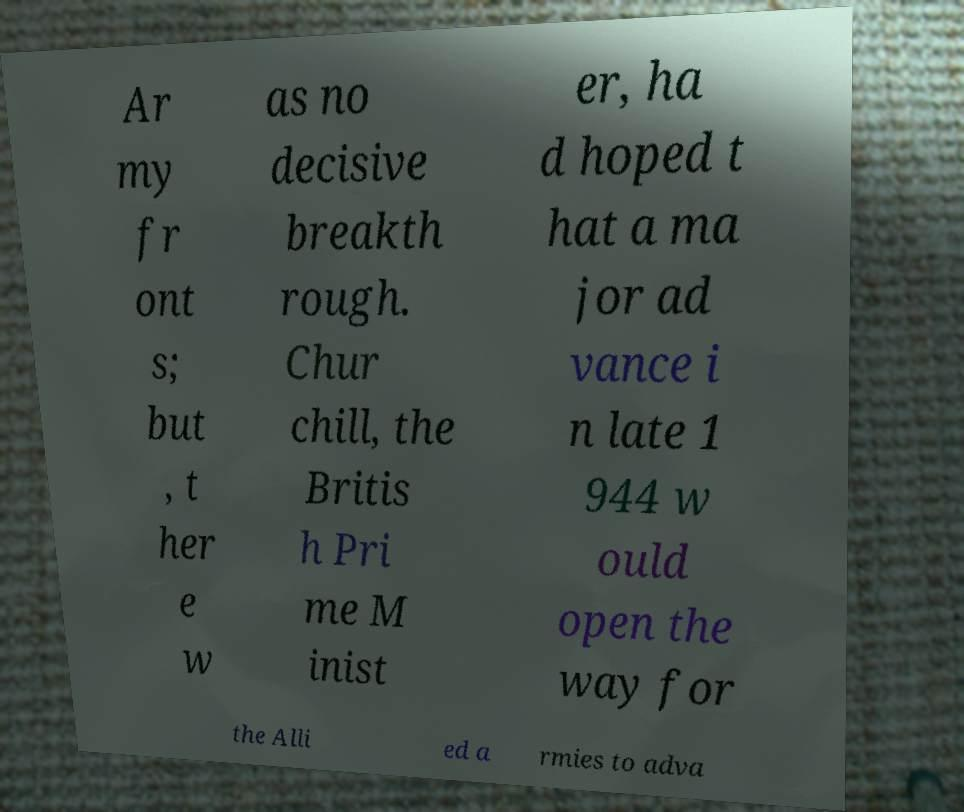Can you read and provide the text displayed in the image?This photo seems to have some interesting text. Can you extract and type it out for me? Ar my fr ont s; but , t her e w as no decisive breakth rough. Chur chill, the Britis h Pri me M inist er, ha d hoped t hat a ma jor ad vance i n late 1 944 w ould open the way for the Alli ed a rmies to adva 